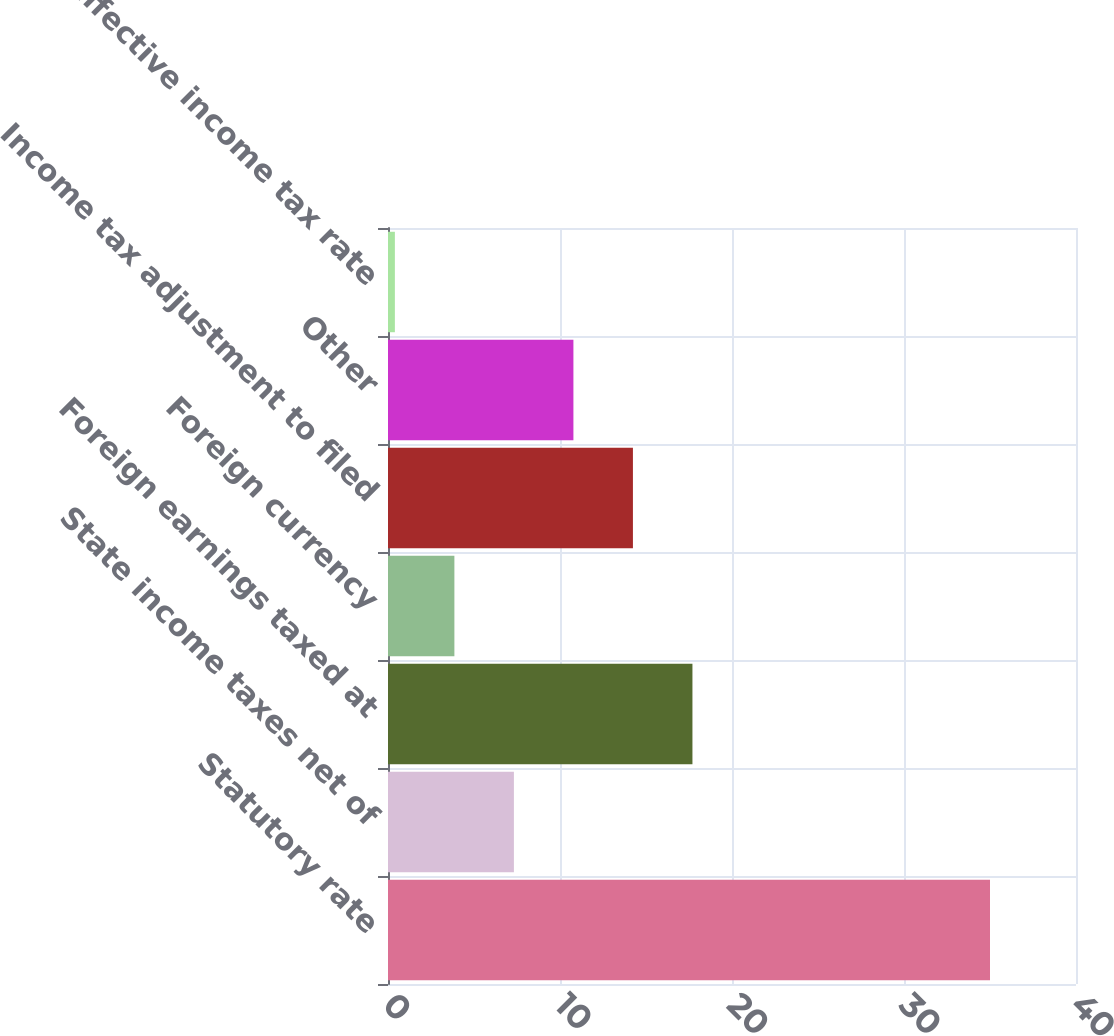Convert chart. <chart><loc_0><loc_0><loc_500><loc_500><bar_chart><fcel>Statutory rate<fcel>State income taxes net of<fcel>Foreign earnings taxed at<fcel>Foreign currency<fcel>Income tax adjustment to filed<fcel>Other<fcel>Effective income tax rate<nl><fcel>35<fcel>7.32<fcel>17.7<fcel>3.86<fcel>14.24<fcel>10.78<fcel>0.4<nl></chart> 